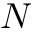<formula> <loc_0><loc_0><loc_500><loc_500>N</formula> 